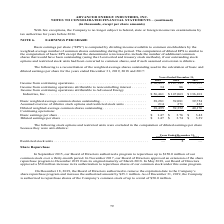According to Advanced Energy's financial document, How was Basic earnings per share (“EPS”) computed by the company? by dividing income available to common stockholders by the weighted-average number of common shares outstanding during the period.. The document states: "Basic earnings per share (“EPS”) is computed by dividing income available to common stockholders by the weighted-average number of common shares outst..." Also, What was the Income from continuing operations attributable to Advanced Energy Industries, Inc. in 2017? According to the financial document, $136,101 (in thousands). The relevant text states: "from continuing operations . $ 56,495 $ 147,149 $ 136,101 Income from continuing operations attributable to noncontrolling interest . 34 86 — Income from con..." Also, What was the Basic weighted-average common shares outstanding in 2019? According to the financial document, 38,281 (in thousands). The relevant text states: "asic weighted-average common shares outstanding . 38,281 39,081 39,754 Assumed exercise of dilutive stock options and restricted stock units . 214 271 422 D..." Also, can you calculate: What was the change in Assumed exercise of dilutive stock options and restricted stock units between 2018 and 2019? Based on the calculation: 214-271, the result is -57 (in thousands). This is based on the information: "ve stock options and restricted stock units . 214 271 422 Diluted weighted-average common shares outstanding . 38,495 39,352 40,176 Continuing operations lutive stock options and restricted stock unit..." The key data points involved are: 214, 271. Also, can you calculate: What was the change in Diluted weighted-average common shares outstanding between 2018 and 2019? Based on the calculation: 38,495-39,352, the result is -857 (in thousands). This is based on the information: "ighted-average common shares outstanding . 38,495 39,352 40,176 Continuing operations: uted weighted-average common shares outstanding . 38,495 39,352 40,176 Continuing operations:..." The key data points involved are: 38,495, 39,352. Also, can you calculate: What was the percentage change in Income from continuing operations between 2017 and 2018? To answer this question, I need to perform calculations using the financial data. The calculation is: ($147,149-$136,101)/136,101, which equals 8.12 (percentage). This is based on the information: "from continuing operations . $ 56,495 $ 147,149 $ 136,101 Income from continuing operations attributable to noncontrolling interest . 34 86 — Income from con Income from continuing operations . $ 56,4..." The key data points involved are: 136,101, 147,149. 